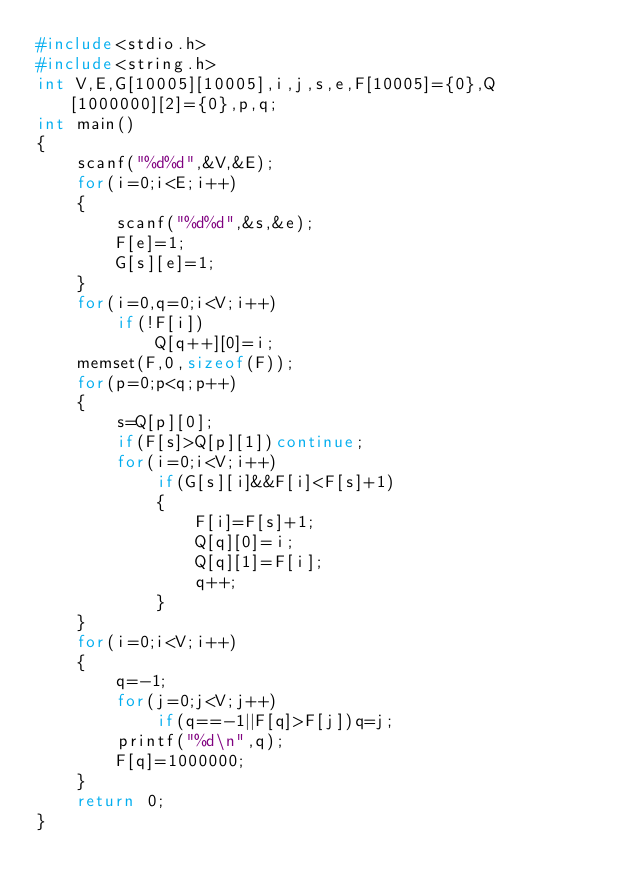<code> <loc_0><loc_0><loc_500><loc_500><_C_>#include<stdio.h>
#include<string.h>
int V,E,G[10005][10005],i,j,s,e,F[10005]={0},Q[1000000][2]={0},p,q;
int main()
{
	scanf("%d%d",&V,&E);
	for(i=0;i<E;i++)
	{
		scanf("%d%d",&s,&e);
		F[e]=1;
		G[s][e]=1;
	}
	for(i=0,q=0;i<V;i++)
		if(!F[i])
			Q[q++][0]=i;
	memset(F,0,sizeof(F));
	for(p=0;p<q;p++)
	{
		s=Q[p][0];
		if(F[s]>Q[p][1])continue;
		for(i=0;i<V;i++)
			if(G[s][i]&&F[i]<F[s]+1)
			{
				F[i]=F[s]+1;
				Q[q][0]=i;
				Q[q][1]=F[i];
				q++;
			}
	}
	for(i=0;i<V;i++)
	{
		q=-1;
		for(j=0;j<V;j++)
			if(q==-1||F[q]>F[j])q=j;
		printf("%d\n",q);
		F[q]=1000000;
	}
	return 0;
}</code> 